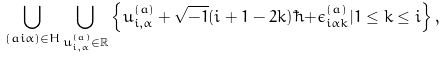Convert formula to latex. <formula><loc_0><loc_0><loc_500><loc_500>\bigcup _ { ( a i \alpha ) \in H } \bigcup _ { u ^ { ( a ) } _ { i , \alpha } \in { \mathbb { R } } } \left \{ u ^ { ( a ) } _ { i , \alpha } + \sqrt { - 1 } ( i + 1 - 2 k ) \hbar { + } \epsilon ^ { ( a ) } _ { i \alpha k } | 1 \leq k \leq i \right \} ,</formula> 